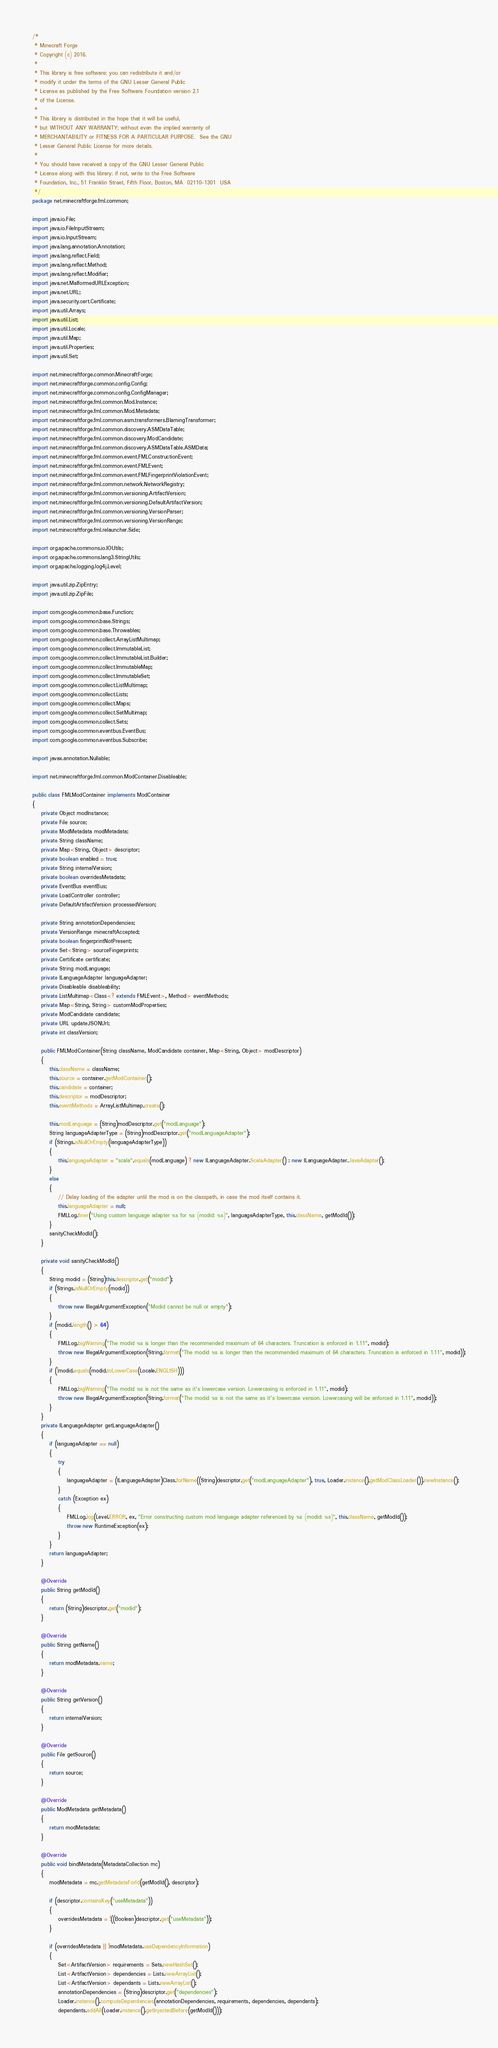<code> <loc_0><loc_0><loc_500><loc_500><_Java_>/*
 * Minecraft Forge
 * Copyright (c) 2016.
 *
 * This library is free software; you can redistribute it and/or
 * modify it under the terms of the GNU Lesser General Public
 * License as published by the Free Software Foundation version 2.1
 * of the License.
 *
 * This library is distributed in the hope that it will be useful,
 * but WITHOUT ANY WARRANTY; without even the implied warranty of
 * MERCHANTABILITY or FITNESS FOR A PARTICULAR PURPOSE.  See the GNU
 * Lesser General Public License for more details.
 *
 * You should have received a copy of the GNU Lesser General Public
 * License along with this library; if not, write to the Free Software
 * Foundation, Inc., 51 Franklin Street, Fifth Floor, Boston, MA  02110-1301  USA
 */
package net.minecraftforge.fml.common;

import java.io.File;
import java.io.FileInputStream;
import java.io.InputStream;
import java.lang.annotation.Annotation;
import java.lang.reflect.Field;
import java.lang.reflect.Method;
import java.lang.reflect.Modifier;
import java.net.MalformedURLException;
import java.net.URL;
import java.security.cert.Certificate;
import java.util.Arrays;
import java.util.List;
import java.util.Locale;
import java.util.Map;
import java.util.Properties;
import java.util.Set;

import net.minecraftforge.common.MinecraftForge;
import net.minecraftforge.common.config.Config;
import net.minecraftforge.common.config.ConfigManager;
import net.minecraftforge.fml.common.Mod.Instance;
import net.minecraftforge.fml.common.Mod.Metadata;
import net.minecraftforge.fml.common.asm.transformers.BlamingTransformer;
import net.minecraftforge.fml.common.discovery.ASMDataTable;
import net.minecraftforge.fml.common.discovery.ModCandidate;
import net.minecraftforge.fml.common.discovery.ASMDataTable.ASMData;
import net.minecraftforge.fml.common.event.FMLConstructionEvent;
import net.minecraftforge.fml.common.event.FMLEvent;
import net.minecraftforge.fml.common.event.FMLFingerprintViolationEvent;
import net.minecraftforge.fml.common.network.NetworkRegistry;
import net.minecraftforge.fml.common.versioning.ArtifactVersion;
import net.minecraftforge.fml.common.versioning.DefaultArtifactVersion;
import net.minecraftforge.fml.common.versioning.VersionParser;
import net.minecraftforge.fml.common.versioning.VersionRange;
import net.minecraftforge.fml.relauncher.Side;

import org.apache.commons.io.IOUtils;
import org.apache.commons.lang3.StringUtils;
import org.apache.logging.log4j.Level;

import java.util.zip.ZipEntry;
import java.util.zip.ZipFile;

import com.google.common.base.Function;
import com.google.common.base.Strings;
import com.google.common.base.Throwables;
import com.google.common.collect.ArrayListMultimap;
import com.google.common.collect.ImmutableList;
import com.google.common.collect.ImmutableList.Builder;
import com.google.common.collect.ImmutableMap;
import com.google.common.collect.ImmutableSet;
import com.google.common.collect.ListMultimap;
import com.google.common.collect.Lists;
import com.google.common.collect.Maps;
import com.google.common.collect.SetMultimap;
import com.google.common.collect.Sets;
import com.google.common.eventbus.EventBus;
import com.google.common.eventbus.Subscribe;

import javax.annotation.Nullable;

import net.minecraftforge.fml.common.ModContainer.Disableable;

public class FMLModContainer implements ModContainer
{
    private Object modInstance;
    private File source;
    private ModMetadata modMetadata;
    private String className;
    private Map<String, Object> descriptor;
    private boolean enabled = true;
    private String internalVersion;
    private boolean overridesMetadata;
    private EventBus eventBus;
    private LoadController controller;
    private DefaultArtifactVersion processedVersion;

    private String annotationDependencies;
    private VersionRange minecraftAccepted;
    private boolean fingerprintNotPresent;
    private Set<String> sourceFingerprints;
    private Certificate certificate;
    private String modLanguage;
    private ILanguageAdapter languageAdapter;
    private Disableable disableability;
    private ListMultimap<Class<? extends FMLEvent>, Method> eventMethods;
    private Map<String, String> customModProperties;
    private ModCandidate candidate;
    private URL updateJSONUrl;
    private int classVersion;

    public FMLModContainer(String className, ModCandidate container, Map<String, Object> modDescriptor)
    {
        this.className = className;
        this.source = container.getModContainer();
        this.candidate = container;
        this.descriptor = modDescriptor;
        this.eventMethods = ArrayListMultimap.create();

        this.modLanguage = (String)modDescriptor.get("modLanguage");
        String languageAdapterType = (String)modDescriptor.get("modLanguageAdapter");
        if (Strings.isNullOrEmpty(languageAdapterType))
        {
            this.languageAdapter = "scala".equals(modLanguage) ? new ILanguageAdapter.ScalaAdapter() : new ILanguageAdapter.JavaAdapter();
        }
        else
        {
            // Delay loading of the adapter until the mod is on the classpath, in case the mod itself contains it.
            this.languageAdapter = null;
            FMLLog.finer("Using custom language adapter %s for %s (modid: %s)", languageAdapterType, this.className, getModId());
        }
        sanityCheckModId();
    }

    private void sanityCheckModId()
    {
        String modid = (String)this.descriptor.get("modid");
        if (Strings.isNullOrEmpty(modid))
        {
            throw new IllegalArgumentException("Modid cannot be null or empty");
        }
        if (modid.length() > 64)
        {
            FMLLog.bigWarning("The modid %s is longer than the recommended maximum of 64 characters. Truncation is enforced in 1.11", modid);
            throw new IllegalArgumentException(String.format("The modid %s is longer than the recommended maximum of 64 characters. Truncation is enforced in 1.11", modid));
        }
        if (!modid.equals(modid.toLowerCase(Locale.ENGLISH)))
        {
            FMLLog.bigWarning("The modid %s is not the same as it's lowercase version. Lowercasing is enforced in 1.11", modid);
            throw new IllegalArgumentException(String.format("The modid %s is not the same as it's lowercase version. Lowercasing will be enforced in 1.11", modid));
        }
    }
    private ILanguageAdapter getLanguageAdapter()
    {
        if (languageAdapter == null)
        {
            try
            {
                languageAdapter = (ILanguageAdapter)Class.forName((String)descriptor.get("modLanguageAdapter"), true, Loader.instance().getModClassLoader()).newInstance();
            }
            catch (Exception ex)
            {
                FMLLog.log(Level.ERROR, ex, "Error constructing custom mod language adapter referenced by %s (modid: %s)", this.className, getModId());
                throw new RuntimeException(ex);
            }
        }
        return languageAdapter;
    }

    @Override
    public String getModId()
    {
        return (String)descriptor.get("modid");
    }

    @Override
    public String getName()
    {
        return modMetadata.name;
    }

    @Override
    public String getVersion()
    {
        return internalVersion;
    }

    @Override
    public File getSource()
    {
        return source;
    }

    @Override
    public ModMetadata getMetadata()
    {
        return modMetadata;
    }

    @Override
    public void bindMetadata(MetadataCollection mc)
    {
        modMetadata = mc.getMetadataForId(getModId(), descriptor);

        if (descriptor.containsKey("useMetadata"))
        {
            overridesMetadata = !((Boolean)descriptor.get("useMetadata"));
        }

        if (overridesMetadata || !modMetadata.useDependencyInformation)
        {
            Set<ArtifactVersion> requirements = Sets.newHashSet();
            List<ArtifactVersion> dependencies = Lists.newArrayList();
            List<ArtifactVersion> dependants = Lists.newArrayList();
            annotationDependencies = (String)descriptor.get("dependencies");
            Loader.instance().computeDependencies(annotationDependencies, requirements, dependencies, dependants);
            dependants.addAll(Loader.instance().getInjectedBefore(getModId()));</code> 